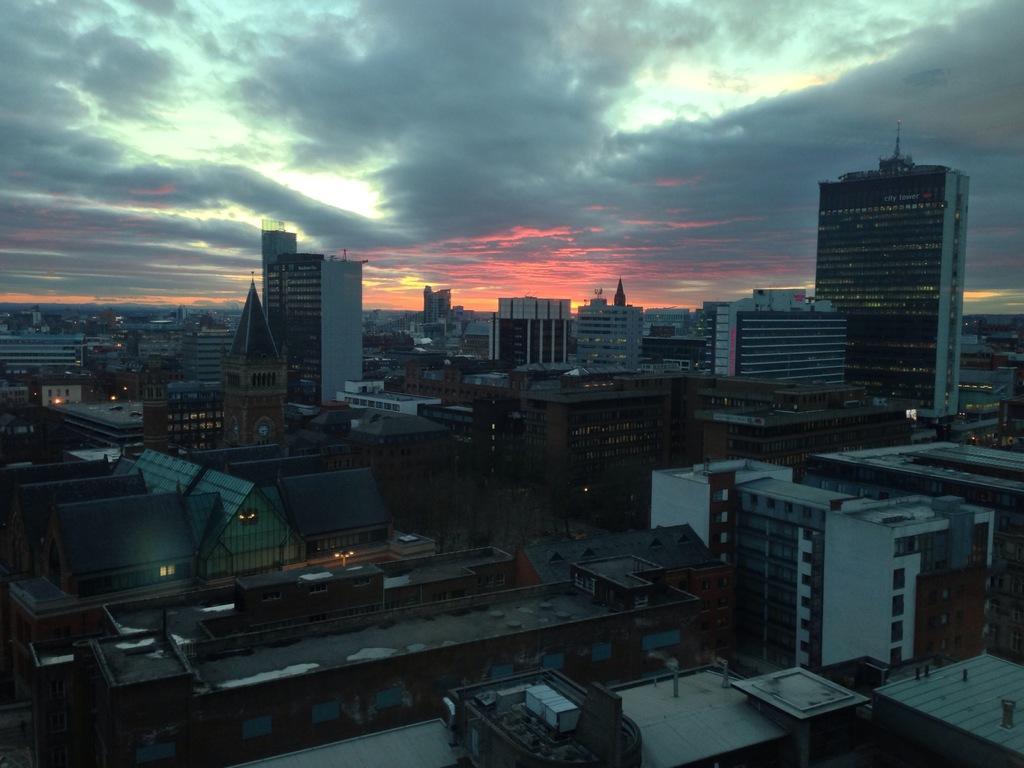Can you describe this image briefly? In the picture I can see buildings. In the background I can see the sky. 